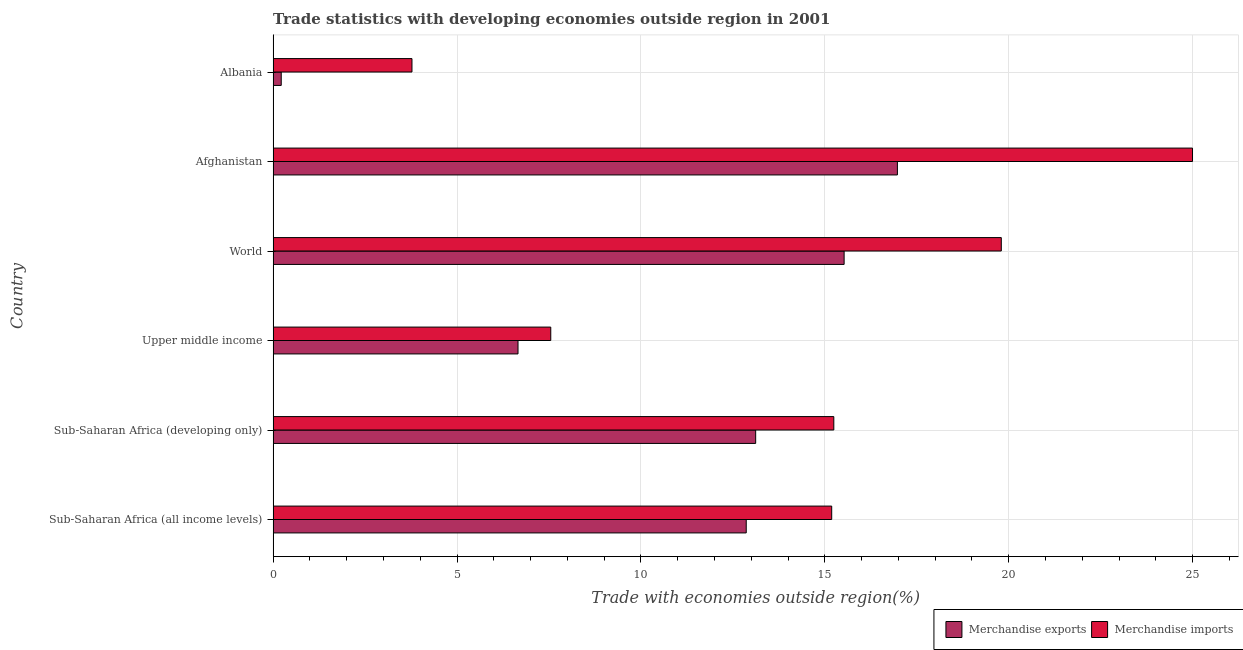How many different coloured bars are there?
Your answer should be compact. 2. Are the number of bars per tick equal to the number of legend labels?
Offer a terse response. Yes. How many bars are there on the 2nd tick from the top?
Keep it short and to the point. 2. What is the label of the 5th group of bars from the top?
Provide a succinct answer. Sub-Saharan Africa (developing only). In how many cases, is the number of bars for a given country not equal to the number of legend labels?
Provide a short and direct response. 0. What is the merchandise exports in Sub-Saharan Africa (all income levels)?
Provide a succinct answer. 12.86. Across all countries, what is the maximum merchandise exports?
Your answer should be compact. 16.97. Across all countries, what is the minimum merchandise imports?
Give a very brief answer. 3.77. In which country was the merchandise imports maximum?
Your answer should be compact. Afghanistan. In which country was the merchandise exports minimum?
Provide a succinct answer. Albania. What is the total merchandise imports in the graph?
Your response must be concise. 86.55. What is the difference between the merchandise exports in Afghanistan and that in World?
Your answer should be compact. 1.45. What is the difference between the merchandise exports in Albania and the merchandise imports in Upper middle income?
Your response must be concise. -7.33. What is the average merchandise imports per country?
Provide a short and direct response. 14.43. What is the difference between the merchandise exports and merchandise imports in Sub-Saharan Africa (all income levels)?
Your answer should be compact. -2.32. In how many countries, is the merchandise imports greater than 23 %?
Your answer should be compact. 1. What is the ratio of the merchandise imports in Afghanistan to that in Sub-Saharan Africa (all income levels)?
Ensure brevity in your answer.  1.65. Is the difference between the merchandise exports in Sub-Saharan Africa (developing only) and Upper middle income greater than the difference between the merchandise imports in Sub-Saharan Africa (developing only) and Upper middle income?
Give a very brief answer. No. What is the difference between the highest and the second highest merchandise imports?
Provide a succinct answer. 5.2. What is the difference between the highest and the lowest merchandise exports?
Keep it short and to the point. 16.75. What does the 1st bar from the top in World represents?
Offer a very short reply. Merchandise imports. How many bars are there?
Offer a very short reply. 12. Are all the bars in the graph horizontal?
Your response must be concise. Yes. Does the graph contain any zero values?
Your answer should be very brief. No. What is the title of the graph?
Offer a very short reply. Trade statistics with developing economies outside region in 2001. Does "Revenue" appear as one of the legend labels in the graph?
Ensure brevity in your answer.  No. What is the label or title of the X-axis?
Your answer should be very brief. Trade with economies outside region(%). What is the label or title of the Y-axis?
Your answer should be compact. Country. What is the Trade with economies outside region(%) in Merchandise exports in Sub-Saharan Africa (all income levels)?
Your response must be concise. 12.86. What is the Trade with economies outside region(%) of Merchandise imports in Sub-Saharan Africa (all income levels)?
Offer a terse response. 15.19. What is the Trade with economies outside region(%) of Merchandise exports in Sub-Saharan Africa (developing only)?
Provide a short and direct response. 13.12. What is the Trade with economies outside region(%) in Merchandise imports in Sub-Saharan Africa (developing only)?
Your answer should be compact. 15.24. What is the Trade with economies outside region(%) in Merchandise exports in Upper middle income?
Keep it short and to the point. 6.66. What is the Trade with economies outside region(%) in Merchandise imports in Upper middle income?
Make the answer very short. 7.55. What is the Trade with economies outside region(%) of Merchandise exports in World?
Make the answer very short. 15.52. What is the Trade with economies outside region(%) in Merchandise imports in World?
Your answer should be very brief. 19.8. What is the Trade with economies outside region(%) of Merchandise exports in Afghanistan?
Your response must be concise. 16.97. What is the Trade with economies outside region(%) of Merchandise imports in Afghanistan?
Your response must be concise. 25. What is the Trade with economies outside region(%) in Merchandise exports in Albania?
Offer a terse response. 0.22. What is the Trade with economies outside region(%) of Merchandise imports in Albania?
Make the answer very short. 3.77. Across all countries, what is the maximum Trade with economies outside region(%) of Merchandise exports?
Keep it short and to the point. 16.97. Across all countries, what is the maximum Trade with economies outside region(%) of Merchandise imports?
Your answer should be compact. 25. Across all countries, what is the minimum Trade with economies outside region(%) of Merchandise exports?
Your answer should be very brief. 0.22. Across all countries, what is the minimum Trade with economies outside region(%) of Merchandise imports?
Keep it short and to the point. 3.77. What is the total Trade with economies outside region(%) in Merchandise exports in the graph?
Give a very brief answer. 65.36. What is the total Trade with economies outside region(%) of Merchandise imports in the graph?
Offer a terse response. 86.55. What is the difference between the Trade with economies outside region(%) of Merchandise exports in Sub-Saharan Africa (all income levels) and that in Sub-Saharan Africa (developing only)?
Your response must be concise. -0.26. What is the difference between the Trade with economies outside region(%) of Merchandise imports in Sub-Saharan Africa (all income levels) and that in Sub-Saharan Africa (developing only)?
Keep it short and to the point. -0.06. What is the difference between the Trade with economies outside region(%) of Merchandise exports in Sub-Saharan Africa (all income levels) and that in Upper middle income?
Ensure brevity in your answer.  6.21. What is the difference between the Trade with economies outside region(%) in Merchandise imports in Sub-Saharan Africa (all income levels) and that in Upper middle income?
Provide a short and direct response. 7.64. What is the difference between the Trade with economies outside region(%) of Merchandise exports in Sub-Saharan Africa (all income levels) and that in World?
Give a very brief answer. -2.66. What is the difference between the Trade with economies outside region(%) in Merchandise imports in Sub-Saharan Africa (all income levels) and that in World?
Ensure brevity in your answer.  -4.61. What is the difference between the Trade with economies outside region(%) of Merchandise exports in Sub-Saharan Africa (all income levels) and that in Afghanistan?
Offer a terse response. -4.11. What is the difference between the Trade with economies outside region(%) in Merchandise imports in Sub-Saharan Africa (all income levels) and that in Afghanistan?
Your answer should be very brief. -9.81. What is the difference between the Trade with economies outside region(%) in Merchandise exports in Sub-Saharan Africa (all income levels) and that in Albania?
Your answer should be compact. 12.64. What is the difference between the Trade with economies outside region(%) of Merchandise imports in Sub-Saharan Africa (all income levels) and that in Albania?
Your answer should be compact. 11.41. What is the difference between the Trade with economies outside region(%) in Merchandise exports in Sub-Saharan Africa (developing only) and that in Upper middle income?
Your answer should be very brief. 6.46. What is the difference between the Trade with economies outside region(%) in Merchandise imports in Sub-Saharan Africa (developing only) and that in Upper middle income?
Make the answer very short. 7.7. What is the difference between the Trade with economies outside region(%) in Merchandise exports in Sub-Saharan Africa (developing only) and that in World?
Keep it short and to the point. -2.4. What is the difference between the Trade with economies outside region(%) of Merchandise imports in Sub-Saharan Africa (developing only) and that in World?
Make the answer very short. -4.55. What is the difference between the Trade with economies outside region(%) in Merchandise exports in Sub-Saharan Africa (developing only) and that in Afghanistan?
Your response must be concise. -3.85. What is the difference between the Trade with economies outside region(%) of Merchandise imports in Sub-Saharan Africa (developing only) and that in Afghanistan?
Offer a very short reply. -9.75. What is the difference between the Trade with economies outside region(%) of Merchandise exports in Sub-Saharan Africa (developing only) and that in Albania?
Provide a short and direct response. 12.9. What is the difference between the Trade with economies outside region(%) of Merchandise imports in Sub-Saharan Africa (developing only) and that in Albania?
Keep it short and to the point. 11.47. What is the difference between the Trade with economies outside region(%) of Merchandise exports in Upper middle income and that in World?
Your response must be concise. -8.87. What is the difference between the Trade with economies outside region(%) in Merchandise imports in Upper middle income and that in World?
Offer a terse response. -12.25. What is the difference between the Trade with economies outside region(%) in Merchandise exports in Upper middle income and that in Afghanistan?
Ensure brevity in your answer.  -10.31. What is the difference between the Trade with economies outside region(%) in Merchandise imports in Upper middle income and that in Afghanistan?
Keep it short and to the point. -17.45. What is the difference between the Trade with economies outside region(%) in Merchandise exports in Upper middle income and that in Albania?
Your answer should be compact. 6.44. What is the difference between the Trade with economies outside region(%) in Merchandise imports in Upper middle income and that in Albania?
Offer a terse response. 3.77. What is the difference between the Trade with economies outside region(%) in Merchandise exports in World and that in Afghanistan?
Ensure brevity in your answer.  -1.45. What is the difference between the Trade with economies outside region(%) of Merchandise imports in World and that in Afghanistan?
Provide a succinct answer. -5.2. What is the difference between the Trade with economies outside region(%) in Merchandise exports in World and that in Albania?
Keep it short and to the point. 15.3. What is the difference between the Trade with economies outside region(%) of Merchandise imports in World and that in Albania?
Provide a succinct answer. 16.02. What is the difference between the Trade with economies outside region(%) in Merchandise exports in Afghanistan and that in Albania?
Your response must be concise. 16.75. What is the difference between the Trade with economies outside region(%) of Merchandise imports in Afghanistan and that in Albania?
Provide a short and direct response. 21.22. What is the difference between the Trade with economies outside region(%) in Merchandise exports in Sub-Saharan Africa (all income levels) and the Trade with economies outside region(%) in Merchandise imports in Sub-Saharan Africa (developing only)?
Keep it short and to the point. -2.38. What is the difference between the Trade with economies outside region(%) in Merchandise exports in Sub-Saharan Africa (all income levels) and the Trade with economies outside region(%) in Merchandise imports in Upper middle income?
Offer a very short reply. 5.31. What is the difference between the Trade with economies outside region(%) in Merchandise exports in Sub-Saharan Africa (all income levels) and the Trade with economies outside region(%) in Merchandise imports in World?
Offer a terse response. -6.93. What is the difference between the Trade with economies outside region(%) in Merchandise exports in Sub-Saharan Africa (all income levels) and the Trade with economies outside region(%) in Merchandise imports in Afghanistan?
Provide a short and direct response. -12.13. What is the difference between the Trade with economies outside region(%) in Merchandise exports in Sub-Saharan Africa (all income levels) and the Trade with economies outside region(%) in Merchandise imports in Albania?
Provide a succinct answer. 9.09. What is the difference between the Trade with economies outside region(%) of Merchandise exports in Sub-Saharan Africa (developing only) and the Trade with economies outside region(%) of Merchandise imports in Upper middle income?
Provide a short and direct response. 5.57. What is the difference between the Trade with economies outside region(%) in Merchandise exports in Sub-Saharan Africa (developing only) and the Trade with economies outside region(%) in Merchandise imports in World?
Give a very brief answer. -6.68. What is the difference between the Trade with economies outside region(%) of Merchandise exports in Sub-Saharan Africa (developing only) and the Trade with economies outside region(%) of Merchandise imports in Afghanistan?
Keep it short and to the point. -11.88. What is the difference between the Trade with economies outside region(%) in Merchandise exports in Sub-Saharan Africa (developing only) and the Trade with economies outside region(%) in Merchandise imports in Albania?
Ensure brevity in your answer.  9.34. What is the difference between the Trade with economies outside region(%) of Merchandise exports in Upper middle income and the Trade with economies outside region(%) of Merchandise imports in World?
Provide a short and direct response. -13.14. What is the difference between the Trade with economies outside region(%) of Merchandise exports in Upper middle income and the Trade with economies outside region(%) of Merchandise imports in Afghanistan?
Keep it short and to the point. -18.34. What is the difference between the Trade with economies outside region(%) of Merchandise exports in Upper middle income and the Trade with economies outside region(%) of Merchandise imports in Albania?
Provide a short and direct response. 2.88. What is the difference between the Trade with economies outside region(%) in Merchandise exports in World and the Trade with economies outside region(%) in Merchandise imports in Afghanistan?
Offer a terse response. -9.47. What is the difference between the Trade with economies outside region(%) of Merchandise exports in World and the Trade with economies outside region(%) of Merchandise imports in Albania?
Ensure brevity in your answer.  11.75. What is the difference between the Trade with economies outside region(%) of Merchandise exports in Afghanistan and the Trade with economies outside region(%) of Merchandise imports in Albania?
Your answer should be very brief. 13.2. What is the average Trade with economies outside region(%) in Merchandise exports per country?
Give a very brief answer. 10.89. What is the average Trade with economies outside region(%) of Merchandise imports per country?
Provide a short and direct response. 14.42. What is the difference between the Trade with economies outside region(%) of Merchandise exports and Trade with economies outside region(%) of Merchandise imports in Sub-Saharan Africa (all income levels)?
Keep it short and to the point. -2.32. What is the difference between the Trade with economies outside region(%) of Merchandise exports and Trade with economies outside region(%) of Merchandise imports in Sub-Saharan Africa (developing only)?
Provide a succinct answer. -2.12. What is the difference between the Trade with economies outside region(%) in Merchandise exports and Trade with economies outside region(%) in Merchandise imports in Upper middle income?
Keep it short and to the point. -0.89. What is the difference between the Trade with economies outside region(%) in Merchandise exports and Trade with economies outside region(%) in Merchandise imports in World?
Offer a terse response. -4.27. What is the difference between the Trade with economies outside region(%) in Merchandise exports and Trade with economies outside region(%) in Merchandise imports in Afghanistan?
Make the answer very short. -8.02. What is the difference between the Trade with economies outside region(%) of Merchandise exports and Trade with economies outside region(%) of Merchandise imports in Albania?
Keep it short and to the point. -3.55. What is the ratio of the Trade with economies outside region(%) of Merchandise exports in Sub-Saharan Africa (all income levels) to that in Sub-Saharan Africa (developing only)?
Offer a very short reply. 0.98. What is the ratio of the Trade with economies outside region(%) of Merchandise exports in Sub-Saharan Africa (all income levels) to that in Upper middle income?
Your answer should be compact. 1.93. What is the ratio of the Trade with economies outside region(%) of Merchandise imports in Sub-Saharan Africa (all income levels) to that in Upper middle income?
Your response must be concise. 2.01. What is the ratio of the Trade with economies outside region(%) of Merchandise exports in Sub-Saharan Africa (all income levels) to that in World?
Your response must be concise. 0.83. What is the ratio of the Trade with economies outside region(%) in Merchandise imports in Sub-Saharan Africa (all income levels) to that in World?
Your answer should be compact. 0.77. What is the ratio of the Trade with economies outside region(%) of Merchandise exports in Sub-Saharan Africa (all income levels) to that in Afghanistan?
Keep it short and to the point. 0.76. What is the ratio of the Trade with economies outside region(%) in Merchandise imports in Sub-Saharan Africa (all income levels) to that in Afghanistan?
Offer a terse response. 0.61. What is the ratio of the Trade with economies outside region(%) in Merchandise exports in Sub-Saharan Africa (all income levels) to that in Albania?
Offer a terse response. 58.31. What is the ratio of the Trade with economies outside region(%) in Merchandise imports in Sub-Saharan Africa (all income levels) to that in Albania?
Offer a terse response. 4.02. What is the ratio of the Trade with economies outside region(%) in Merchandise exports in Sub-Saharan Africa (developing only) to that in Upper middle income?
Provide a succinct answer. 1.97. What is the ratio of the Trade with economies outside region(%) in Merchandise imports in Sub-Saharan Africa (developing only) to that in Upper middle income?
Offer a very short reply. 2.02. What is the ratio of the Trade with economies outside region(%) in Merchandise exports in Sub-Saharan Africa (developing only) to that in World?
Ensure brevity in your answer.  0.85. What is the ratio of the Trade with economies outside region(%) in Merchandise imports in Sub-Saharan Africa (developing only) to that in World?
Your response must be concise. 0.77. What is the ratio of the Trade with economies outside region(%) of Merchandise exports in Sub-Saharan Africa (developing only) to that in Afghanistan?
Offer a terse response. 0.77. What is the ratio of the Trade with economies outside region(%) in Merchandise imports in Sub-Saharan Africa (developing only) to that in Afghanistan?
Provide a short and direct response. 0.61. What is the ratio of the Trade with economies outside region(%) of Merchandise exports in Sub-Saharan Africa (developing only) to that in Albania?
Your answer should be very brief. 59.48. What is the ratio of the Trade with economies outside region(%) of Merchandise imports in Sub-Saharan Africa (developing only) to that in Albania?
Your response must be concise. 4.04. What is the ratio of the Trade with economies outside region(%) in Merchandise exports in Upper middle income to that in World?
Ensure brevity in your answer.  0.43. What is the ratio of the Trade with economies outside region(%) in Merchandise imports in Upper middle income to that in World?
Ensure brevity in your answer.  0.38. What is the ratio of the Trade with economies outside region(%) of Merchandise exports in Upper middle income to that in Afghanistan?
Provide a short and direct response. 0.39. What is the ratio of the Trade with economies outside region(%) of Merchandise imports in Upper middle income to that in Afghanistan?
Ensure brevity in your answer.  0.3. What is the ratio of the Trade with economies outside region(%) of Merchandise exports in Upper middle income to that in Albania?
Offer a terse response. 30.18. What is the ratio of the Trade with economies outside region(%) in Merchandise imports in Upper middle income to that in Albania?
Provide a succinct answer. 2. What is the ratio of the Trade with economies outside region(%) of Merchandise exports in World to that in Afghanistan?
Give a very brief answer. 0.91. What is the ratio of the Trade with economies outside region(%) of Merchandise imports in World to that in Afghanistan?
Give a very brief answer. 0.79. What is the ratio of the Trade with economies outside region(%) in Merchandise exports in World to that in Albania?
Keep it short and to the point. 70.38. What is the ratio of the Trade with economies outside region(%) of Merchandise imports in World to that in Albania?
Offer a very short reply. 5.24. What is the ratio of the Trade with economies outside region(%) in Merchandise exports in Afghanistan to that in Albania?
Your response must be concise. 76.94. What is the ratio of the Trade with economies outside region(%) of Merchandise imports in Afghanistan to that in Albania?
Provide a short and direct response. 6.62. What is the difference between the highest and the second highest Trade with economies outside region(%) of Merchandise exports?
Your response must be concise. 1.45. What is the difference between the highest and the second highest Trade with economies outside region(%) in Merchandise imports?
Your response must be concise. 5.2. What is the difference between the highest and the lowest Trade with economies outside region(%) of Merchandise exports?
Keep it short and to the point. 16.75. What is the difference between the highest and the lowest Trade with economies outside region(%) in Merchandise imports?
Make the answer very short. 21.22. 